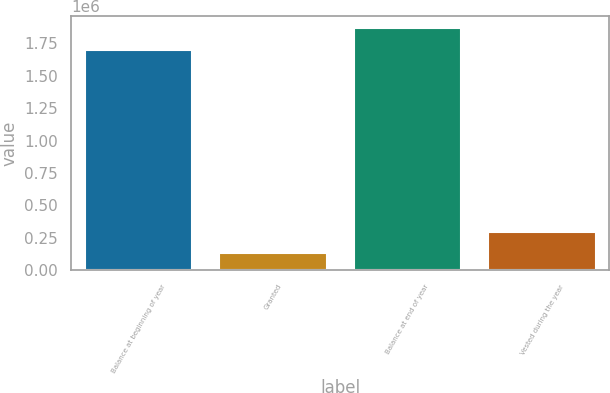Convert chart. <chart><loc_0><loc_0><loc_500><loc_500><bar_chart><fcel>Balance at beginning of year<fcel>Granted<fcel>Balance at end of year<fcel>Vested during the year<nl><fcel>1.6984e+06<fcel>128956<fcel>1.86792e+06<fcel>298479<nl></chart> 